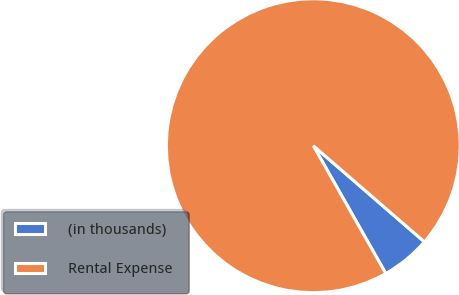Convert chart to OTSL. <chart><loc_0><loc_0><loc_500><loc_500><pie_chart><fcel>(in thousands)<fcel>Rental Expense<nl><fcel>5.44%<fcel>94.56%<nl></chart> 